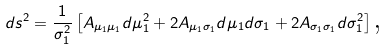Convert formula to latex. <formula><loc_0><loc_0><loc_500><loc_500>d s ^ { 2 } = \frac { 1 } { \sigma _ { 1 } ^ { 2 } } \left [ A _ { \mu _ { 1 } \mu _ { 1 } } d \mu _ { 1 } ^ { 2 } + 2 A _ { \mu _ { 1 } \sigma _ { 1 } } d \mu _ { 1 } d \sigma _ { 1 } + 2 A _ { \sigma _ { 1 } \sigma _ { 1 } } d \sigma _ { 1 } ^ { 2 } \right ] \text {,}</formula> 